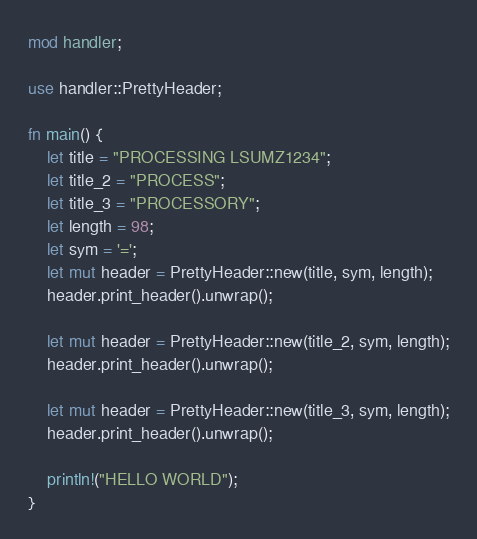Convert code to text. <code><loc_0><loc_0><loc_500><loc_500><_Rust_>mod handler;

use handler::PrettyHeader;

fn main() {
    let title = "PROCESSING LSUMZ1234";
    let title_2 = "PROCESS";
    let title_3 = "PROCESSORY";
    let length = 98;
    let sym = '=';
    let mut header = PrettyHeader::new(title, sym, length);
    header.print_header().unwrap();

    let mut header = PrettyHeader::new(title_2, sym, length);
    header.print_header().unwrap();

    let mut header = PrettyHeader::new(title_3, sym, length);
    header.print_header().unwrap();

    println!("HELLO WORLD");
}



</code> 